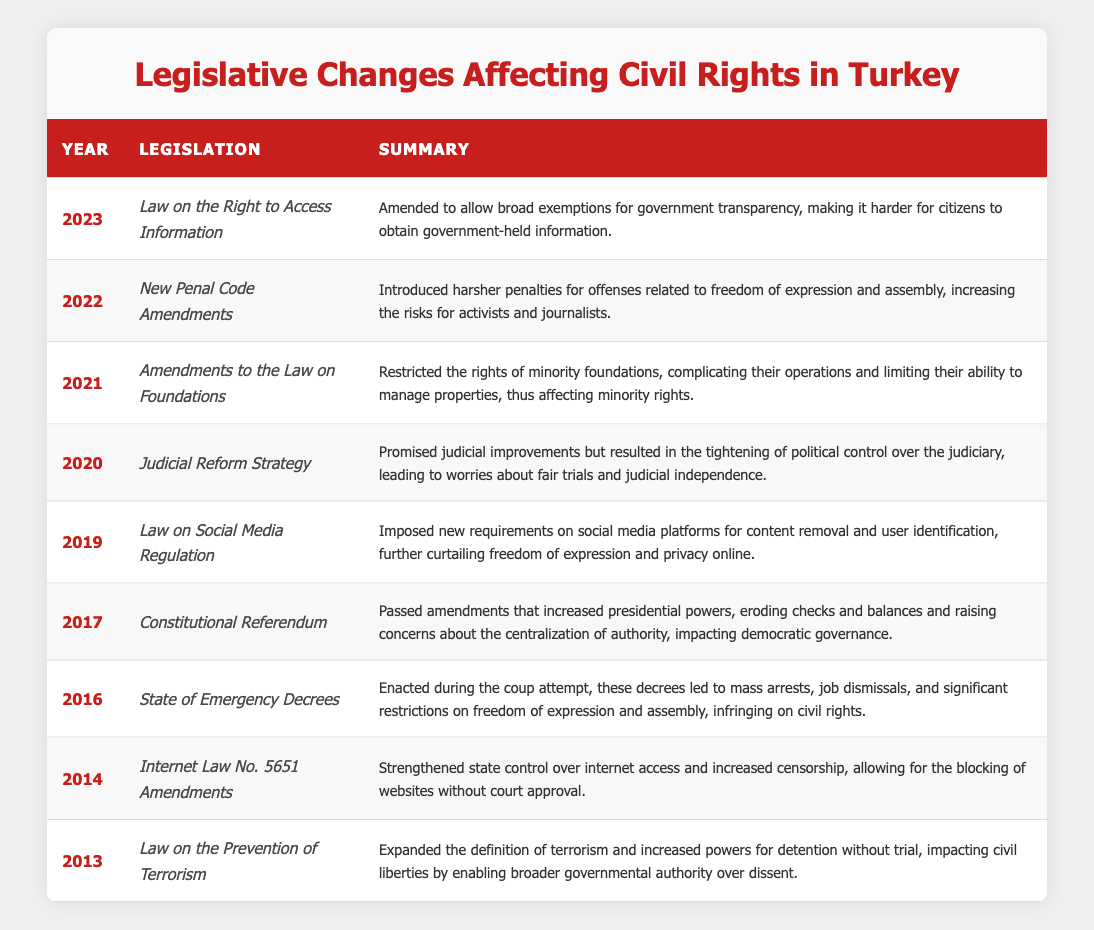What year did the "Law on the Right to Access Information" come into effect? The table lists the legislation along with their respective years. The "Law on the Right to Access Information" is mentioned in the year 2023.
Answer: 2023 Which legislation was enacted in 2016? According to the table, the legislation mentioned for the year 2016 is the "State of Emergency Decrees."
Answer: State of Emergency Decrees How many pieces of legislation directly restricted freedom of expression or assembly? The table outlines several pieces of legislation that impact civil rights. The "State of Emergency Decrees" (2016), "Law on Social Media Regulation" (2019), and "New Penal Code Amendments" (2022) all restrict these freedoms, totaling three.
Answer: Three Did the "Constitutional Referendum" increase presidential powers? The summary for the "Constitutional Referendum" in 2017 explicitly states that it passed amendments that increased presidential powers, which indicates a yes answer.
Answer: Yes What is the difference in years between the enactment of the "Internet Law No. 5651 Amendments" and the "Amendments to the Law on Foundations"? The "Internet Law No. 5651 Amendments" was enacted in 2014 and the "Amendments to the Law on Foundations" in 2021. The difference in years is 2021 - 2014 = 7 years.
Answer: 7 years What are the two most recent legislative changes affecting civil rights? Reviewing the table by year, the most recent pieces of legislation are the "Law on the Right to Access Information" (2023) and "New Penal Code Amendments" (2022).
Answer: Law on the Right to Access Information, New Penal Code Amendments How has the "Judicial Reform Strategy" affected judicial independence? The summary for the "Judicial Reform Strategy" in 2020 mentions results in increased political control over the judiciary, which raises concerns about judicial independence. This indicates that it negatively affected independence.
Answer: Yes Which legislation imposed new requirements on social media platforms? Looking at the table, the "Law on Social Media Regulation" enacted in 2019 specifically mentions imposing new requirements on social media platforms.
Answer: Law on Social Media Regulation How many legislative changes were made in the years following the attempted coup in Turkey? The attempted coup occurred in 2016; from that year onward, the subsequent legislative changes are in 2017, 2019, 2020, 2021, 2022, and 2023, totaling six legislative changes.
Answer: Six 